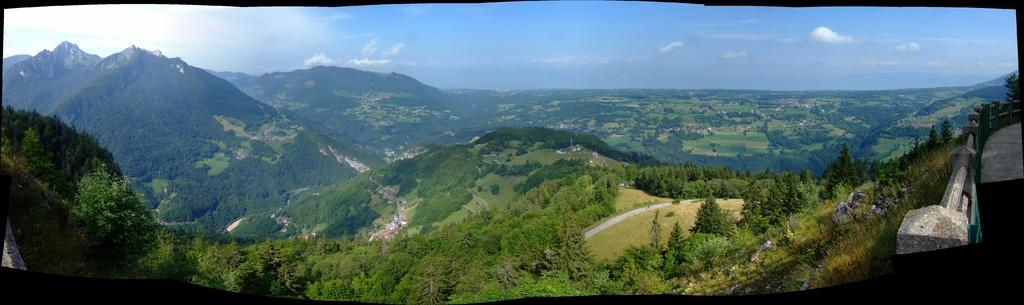What type of natural landscape can be seen in the background of the image? In the background of the image, there are mountains, trees, and houses. What type of vegetation is present at the bottom of the image? At the bottom of the image, there are plants and grass. What part of the natural environment is visible in the image? The sky is visible at the top of the image. Where is the attention of the son in the image? There is no son present in the image, so it is not possible to determine where the attention of a son might be. What type of food is being served in the lunchroom in the image? There is no lunchroom present in the image, so it is not possible to determine what type of food might be served there. 